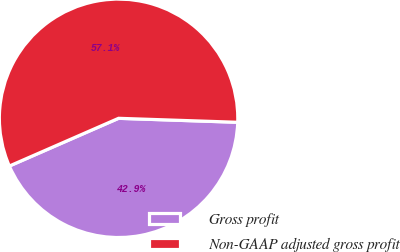<chart> <loc_0><loc_0><loc_500><loc_500><pie_chart><fcel>Gross profit<fcel>Non-GAAP adjusted gross profit<nl><fcel>42.91%<fcel>57.09%<nl></chart> 